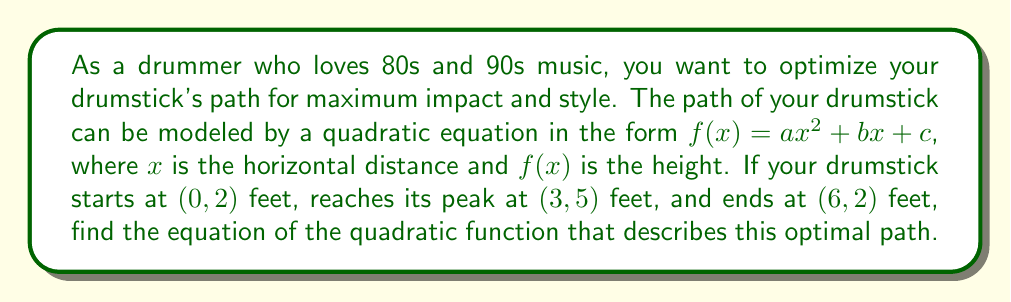Solve this math problem. Let's approach this step-by-step:

1) We know the quadratic function has the form $f(x) = ax^2 + bx + c$.

2) We have three points that the function must pass through:
   (0, 2), (3, 5), and (6, 2)

3) Let's start by using the point (0, 2):
   $f(0) = a(0)^2 + b(0) + c = 2$
   Therefore, $c = 2$

4) Now we can use the other two points to create a system of equations:
   $f(3) = a(3)^2 + b(3) + 2 = 5$
   $f(6) = a(6)^2 + b(6) + 2 = 2$

5) Simplify these equations:
   $9a + 3b = 3$  (Equation 1)
   $36a + 6b = 0$ (Equation 2)

6) Multiply Equation 1 by 4:
   $36a + 12b = 12$ (Equation 3)

7) Subtract Equation 2 from Equation 3:
   $6b = 12$
   $b = 2$

8) Substitute $b = 2$ into Equation 1:
   $9a + 3(2) = 3$
   $9a = -3$
   $a = -\frac{1}{3}$

9) Now we have all the coefficients:
   $a = -\frac{1}{3}$, $b = 2$, and $c = 2$

10) Therefore, the quadratic function is:
    $f(x) = -\frac{1}{3}x^2 + 2x + 2$
Answer: $f(x) = -\frac{1}{3}x^2 + 2x + 2$ 